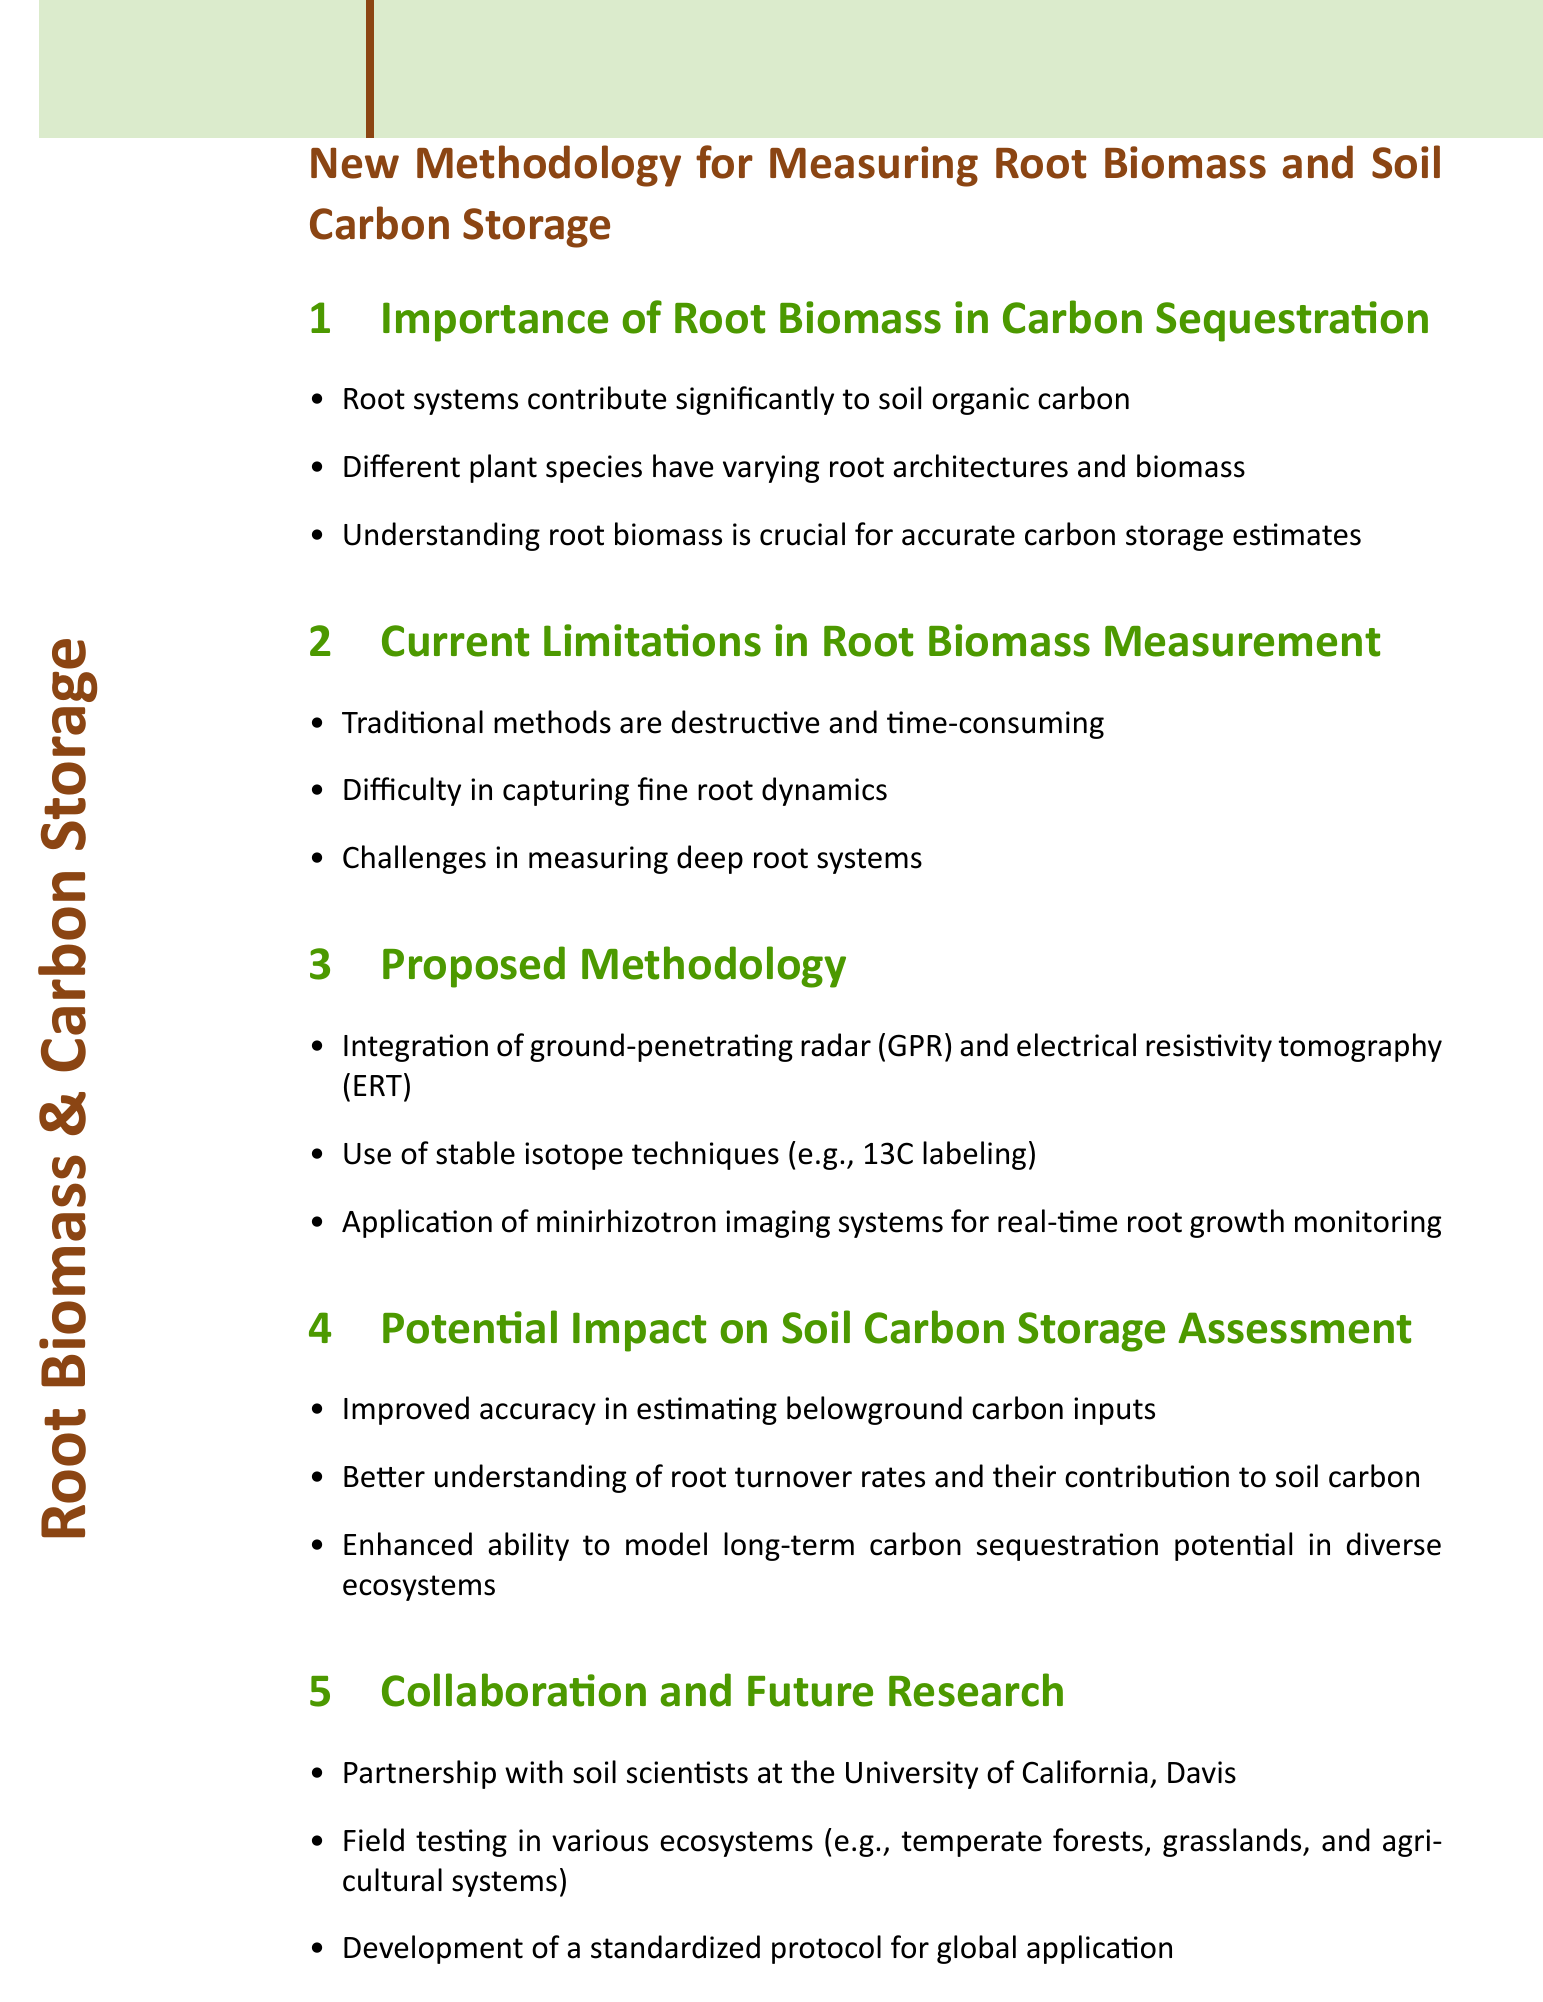What is the title of the document? The title of the document is typically displayed at the beginning of the document.
Answer: New Methodology for Measuring Root Biomass and Soil Carbon Storage What significant contribution do root systems make? This information is found in the first section, which discusses root biomass.
Answer: Soil organic carbon What are traditional methods of measuring root biomass described as? The limitations of current methods are listed in the second section.
Answer: Destructive and time-consuming What techniques are proposed for the new methodology? The proposed methodology includes a list of techniques in the third section.
Answer: Ground-penetrating radar and electrical resistivity tomography Which university is mentioned for collaboration? This information is from the last section, which notes partnerships for research.
Answer: University of California, Davis How will the new methodology impact soil carbon storage assessment? The potential impact is discussed in the fourth section and involves improvement in several areas.
Answer: Improved accuracy in estimating belowground carbon inputs What is one proposed application for monitoring root growth? This is mentioned specifically under the proposed methodologies.
Answer: Minirhizotron imaging systems What ecosystems are suggested for field testing? Possible ecosystems for testing are mentioned in the collaboration section.
Answer: Temperate forests, grasslands, and agricultural systems 